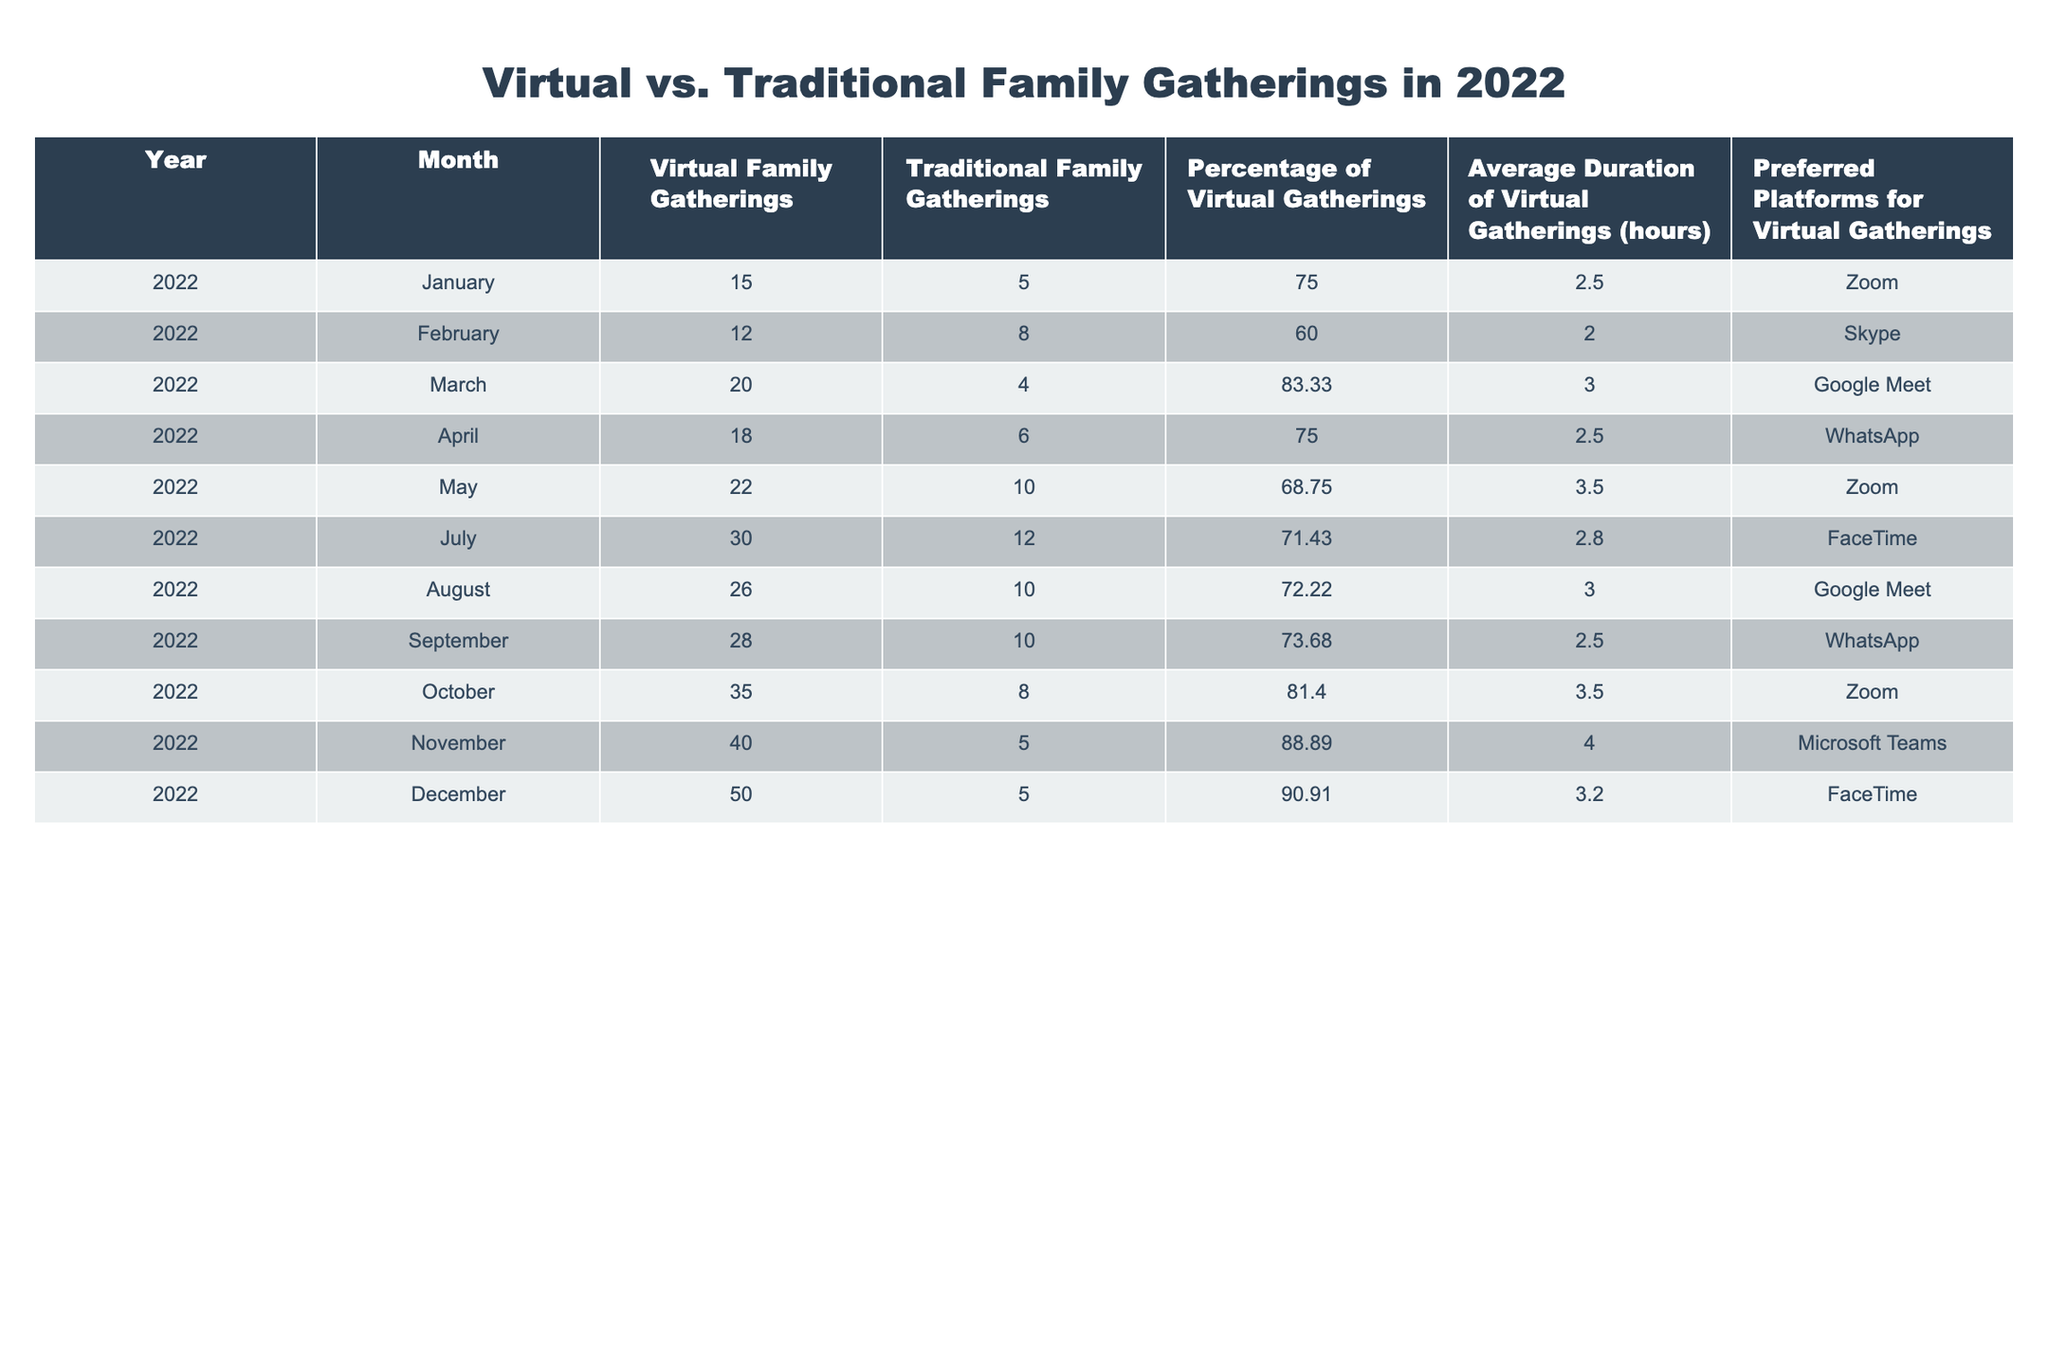What's the total number of virtual family gatherings in March 2022? In March 2022, the table shows a total of 20 virtual family gatherings.
Answer: 20 How many traditional family gatherings were held in the month of October 2022? In October 2022, there were 8 traditional family gatherings according to the table.
Answer: 8 What was the average duration of virtual family gatherings in November 2022? The table indicates that the average duration of virtual family gatherings in November 2022 was 4.0 hours.
Answer: 4.0 Which month had the highest percentage of virtual gatherings? By examining the percentage of virtual gatherings, November 2022 had the highest percentage at 88.89%.
Answer: November What is the difference in the number of virtual family gatherings between April and August 2022? In April, there were 18 virtual family gatherings, and in August, there were 26. The difference is 26 - 18 = 8.
Answer: 8 Did the average duration of virtual family gatherings increase from January to March 2022? In January, the average duration was 2.5 hours and in March, it was 3.0 hours. Since 3.0 is greater than 2.5, it indicates an increase.
Answer: Yes What were the preferred platforms for virtual gatherings in the month with the highest number of virtual gatherings? The month with the highest number of virtual gatherings was December with 50 gatherings, and the preferred platform for that month was FaceTime.
Answer: FaceTime What is the total number of traditional family gatherings held in 2022? Adding the values for traditional family gatherings over all months: 5 + 8 + 4 + 6 + 10 + 12 + 10 + 8 + 5 + 5 = 70.
Answer: 70 Was there a month in 2022 where the percentage of virtual gatherings was below 60%? By checking all months, the lowest percentage of virtual gatherings was in February at 60%, indicating that there were no months below 60%.
Answer: No 